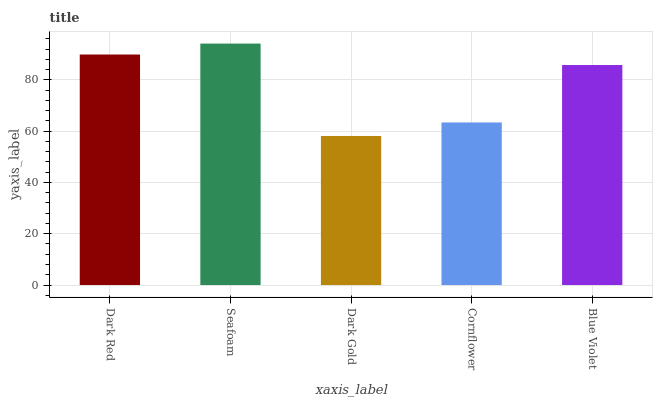Is Seafoam the minimum?
Answer yes or no. No. Is Dark Gold the maximum?
Answer yes or no. No. Is Seafoam greater than Dark Gold?
Answer yes or no. Yes. Is Dark Gold less than Seafoam?
Answer yes or no. Yes. Is Dark Gold greater than Seafoam?
Answer yes or no. No. Is Seafoam less than Dark Gold?
Answer yes or no. No. Is Blue Violet the high median?
Answer yes or no. Yes. Is Blue Violet the low median?
Answer yes or no. Yes. Is Seafoam the high median?
Answer yes or no. No. Is Cornflower the low median?
Answer yes or no. No. 